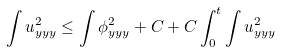Convert formula to latex. <formula><loc_0><loc_0><loc_500><loc_500>\int u _ { y y y } ^ { 2 } \leq \int \phi _ { y y y } ^ { 2 } + C + C \int _ { 0 } ^ { t } \int u _ { y y y } ^ { 2 }</formula> 